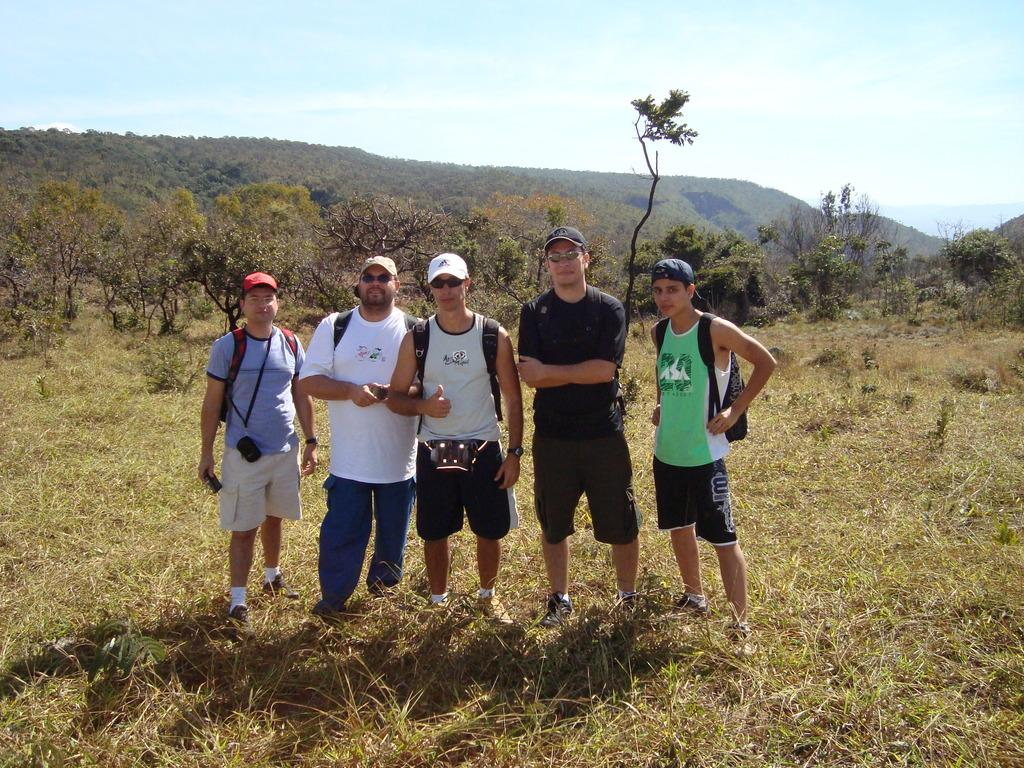What are the people in the image standing on? The people in the image are standing on the grass. What type of vegetation is visible in the image? The grass is visible in the image. What can be seen in the background of the image? There are trees, mountains, and the sky visible in the background of the image. What type of shoes are the people wearing in the image? There is no information about the shoes the people are wearing in the image. Can you describe the nose of the person in the image? There is no person's nose visible in the image. 